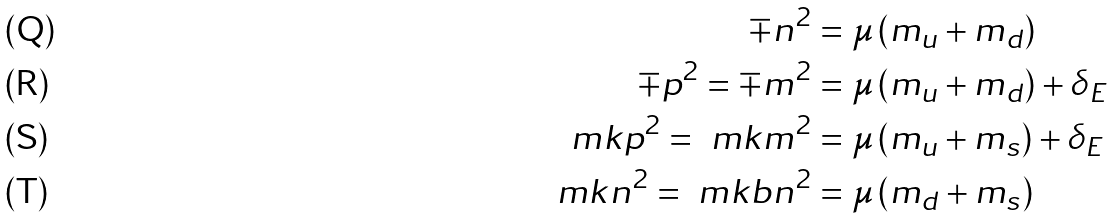Convert formula to latex. <formula><loc_0><loc_0><loc_500><loc_500>\mp n ^ { 2 } & = \mu \left ( m _ { u } + m _ { d } \right ) \\ \mp p ^ { 2 } = \mp m ^ { 2 } & = \mu \left ( m _ { u } + m _ { d } \right ) + \delta _ { E } \\ \ m k p ^ { 2 } = \ m k m ^ { 2 } & = \mu \left ( m _ { u } + m _ { s } \right ) + \delta _ { E } \\ \ m k n ^ { 2 } = \ m k b n ^ { 2 } & = \mu \left ( m _ { d } + m _ { s } \right )</formula> 